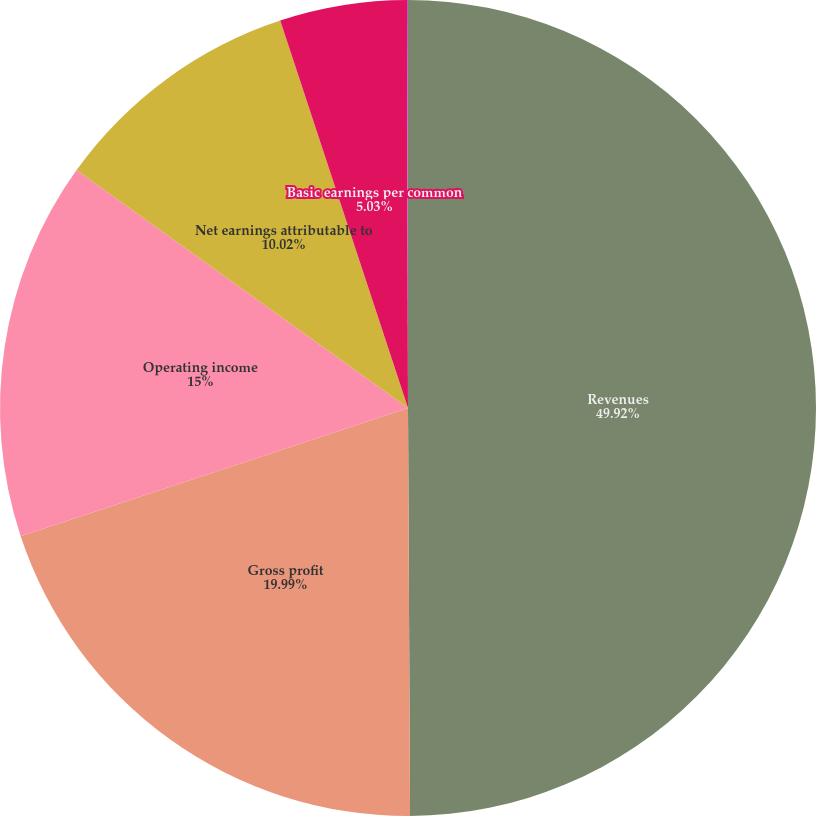<chart> <loc_0><loc_0><loc_500><loc_500><pie_chart><fcel>Revenues<fcel>Gross profit<fcel>Operating income<fcel>Net earnings attributable to<fcel>Basic earnings per common<fcel>Diluted earnings per common<nl><fcel>49.92%<fcel>19.99%<fcel>15.0%<fcel>10.02%<fcel>5.03%<fcel>0.04%<nl></chart> 